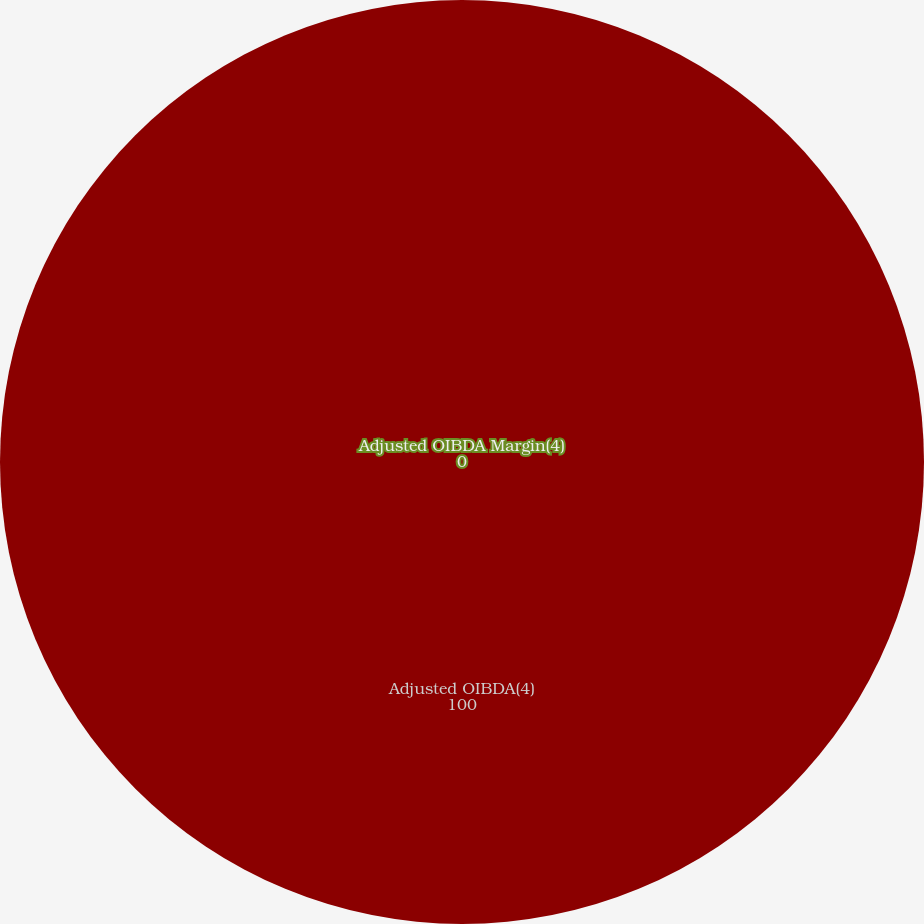Convert chart to OTSL. <chart><loc_0><loc_0><loc_500><loc_500><pie_chart><fcel>Adjusted OIBDA(4)<fcel>Adjusted OIBDA Margin(4)<nl><fcel>100.0%<fcel>0.0%<nl></chart> 